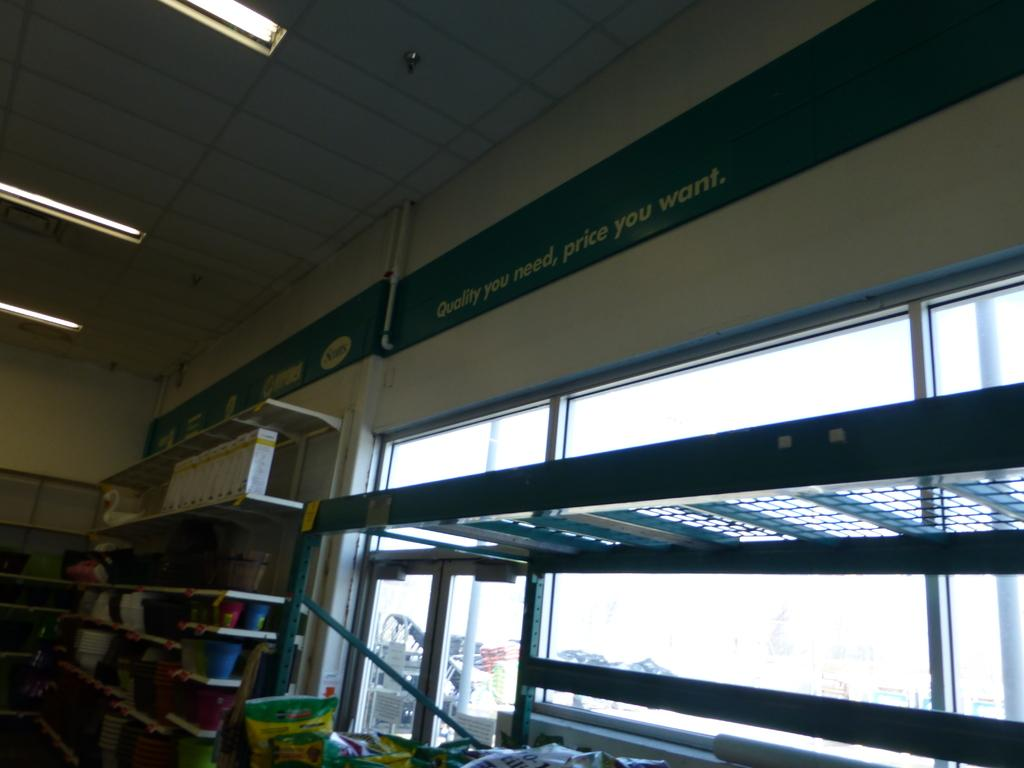<image>
Provide a brief description of the given image. the inside of a store with a banner on the wall that says 'quality you need, price you want' 